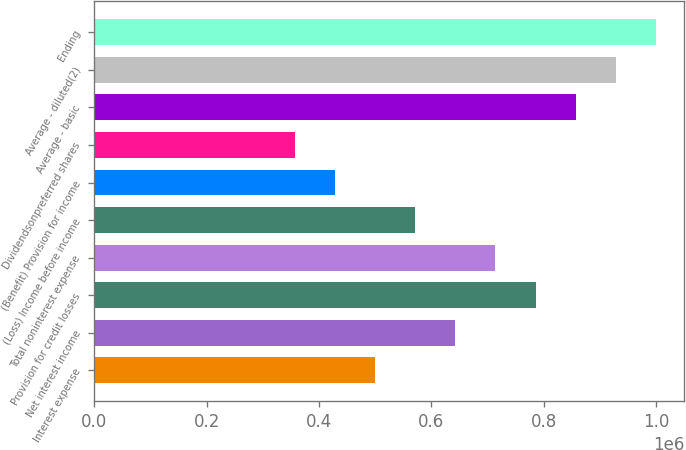Convert chart to OTSL. <chart><loc_0><loc_0><loc_500><loc_500><bar_chart><fcel>Interest expense<fcel>Net interest income<fcel>Provision for credit losses<fcel>Total noninterest expense<fcel>(Loss) Income before income<fcel>(Benefit) Provision for income<fcel>Dividendsonpreferred shares<fcel>Average - basic<fcel>Average - diluted(2)<fcel>Ending<nl><fcel>500128<fcel>643022<fcel>785916<fcel>714469<fcel>571575<fcel>428681<fcel>357235<fcel>857363<fcel>928810<fcel>1.00026e+06<nl></chart> 